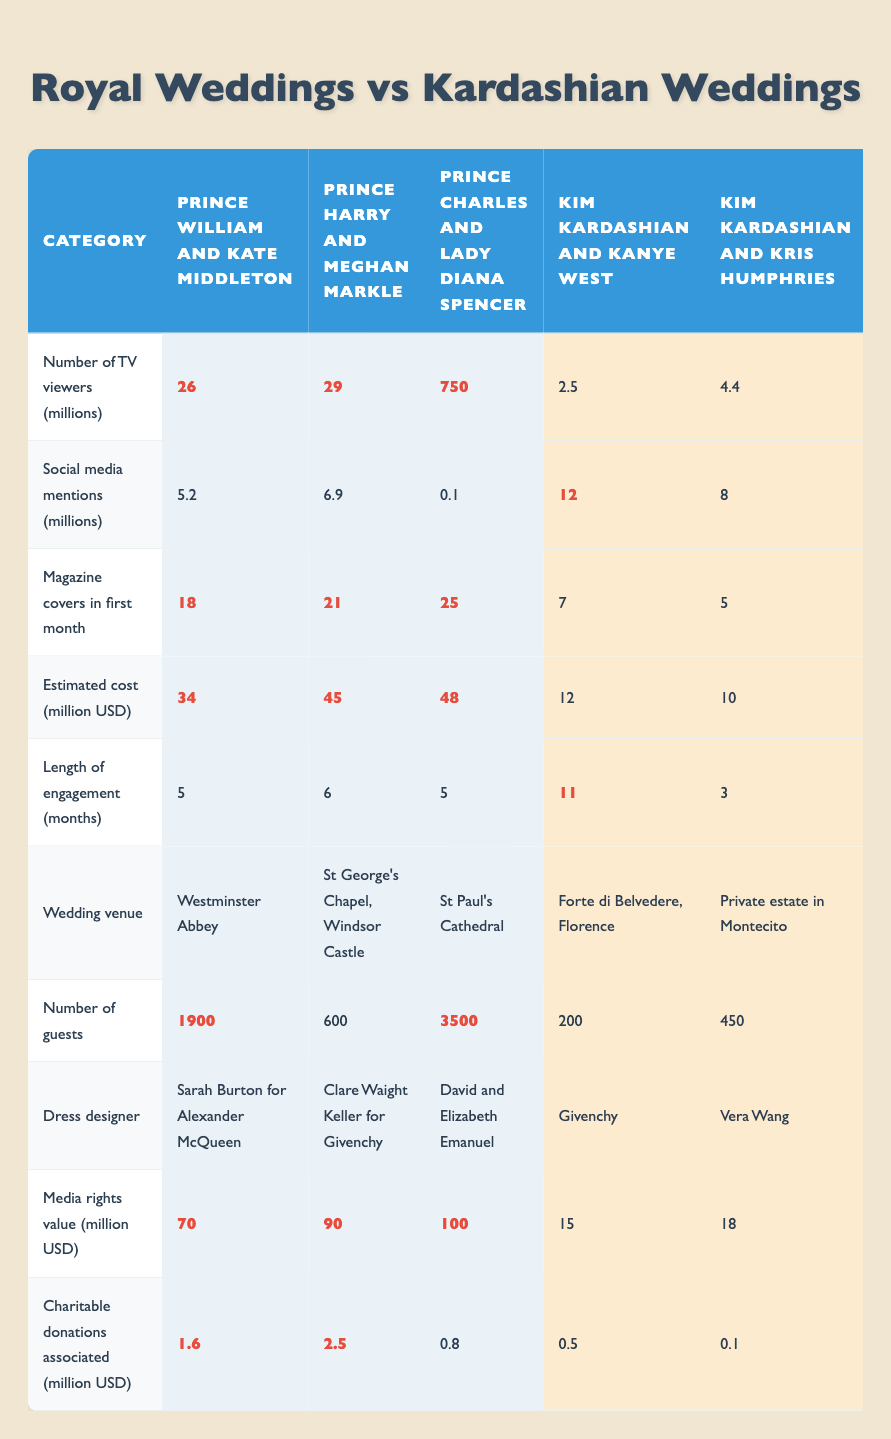What was the highest number of TV viewers for a wedding? The highest number of TV viewers recorded was for the wedding of Prince Charles and Lady Diana Spencer, with 750 million viewers.
Answer: 750 How many social media mentions did Kim Kardashian and Kanye West's wedding receive? Kim Kardashian and Kanye West's wedding received 12 million social media mentions.
Answer: 12 million Which royal wedding had the most magazine covers in its first month? The royal weddings of Prince Charles and Lady Diana Spencer had the most magazine covers, totaling 25 covers in the first month.
Answer: 25 What is the difference in estimated costs between Prince Harry and Meghan Markle's wedding and Kim Kardashian and Kanye West's wedding? The estimated cost of Prince Harry and Meghan Markle’s wedding was 45 million USD, while Kim Kardashian and Kanye West's wedding cost 12 million USD, so the difference is 45 - 12 = 33 million USD.
Answer: 33 million USD Did Kourtney Kardashian and Travis Barker's wedding have more guests than Prince William and Kate Middleton's wedding? No, Kourtney Kardashian and Travis Barker's wedding had 100 guests, which is fewer than the 1900 guests at Prince William and Kate Middleton's wedding.
Answer: No What was the average number of guests for royal weddings, excluding Prince Charles and Lady Diana Spencer's? The average number of guests for the remaining royal weddings (Prince William and Kate Middleton with 1900 guests, Prince Harry and Meghan Markle with 600 guests) is calculated as (1900 + 600)/2 = 1250.
Answer: 1250 Which wedding had the highest media rights value? The wedding of Prince Charles and Lady Diana Spencer had the highest media rights value at 100 million USD.
Answer: 100 million USD Among the Kardashian weddings, which had the lowest charitable donations associated? Kourtney Kardashian and Travis Barker's wedding had the lowest charitable donations associated, totaling 0.2 million USD.
Answer: 0.2 million USD What was the dress designer for Prince Harry and Meghan Markle's wedding? The dress designer for Prince Harry and Meghan Markle's wedding was Clare Waight Keller for Givenchy.
Answer: Clare Waight Keller for Givenchy 